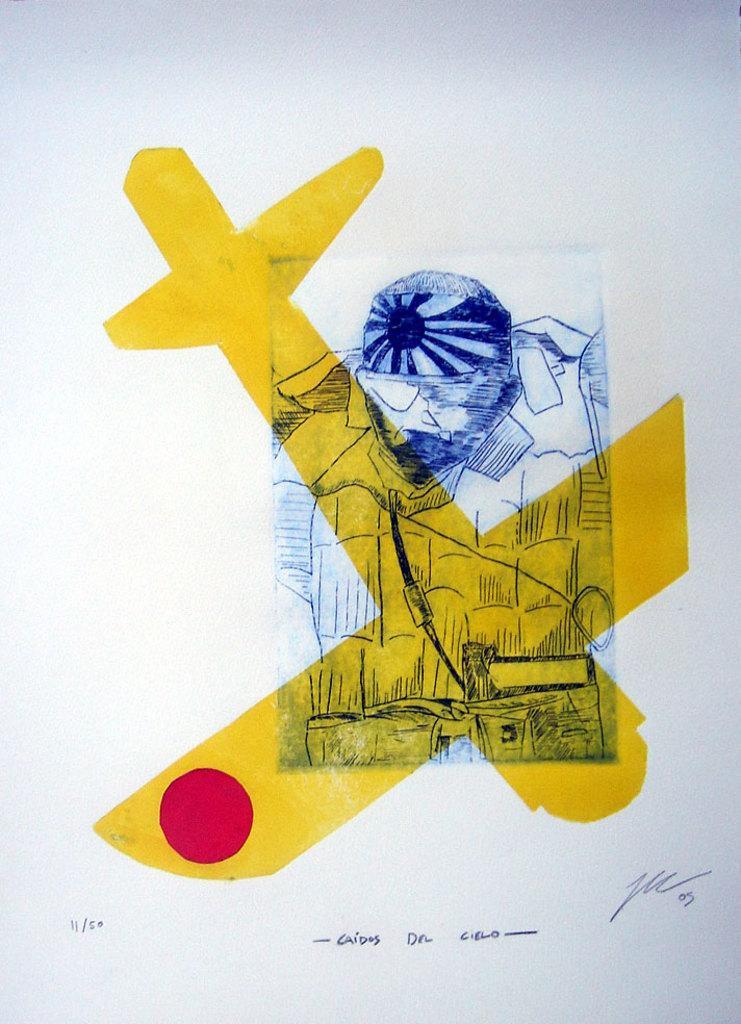Can you describe this image briefly? In this image, this looks like a paper with a drawing on it. I can see the signature on the paper. I think this is a drawing of a person. 